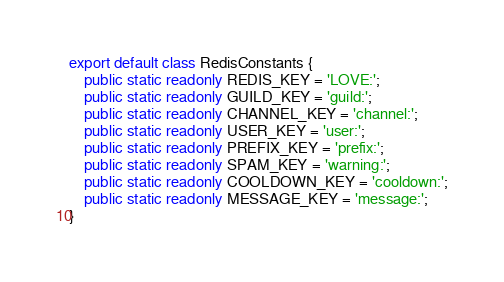Convert code to text. <code><loc_0><loc_0><loc_500><loc_500><_TypeScript_>export default class RedisConstants {
    public static readonly REDIS_KEY = 'LOVE:';
    public static readonly GUILD_KEY = 'guild:';
    public static readonly CHANNEL_KEY = 'channel:';
    public static readonly USER_KEY = 'user:';
    public static readonly PREFIX_KEY = 'prefix:';
    public static readonly SPAM_KEY = 'warning:';
    public static readonly COOLDOWN_KEY = 'cooldown:';
    public static readonly MESSAGE_KEY = 'message:';
}</code> 